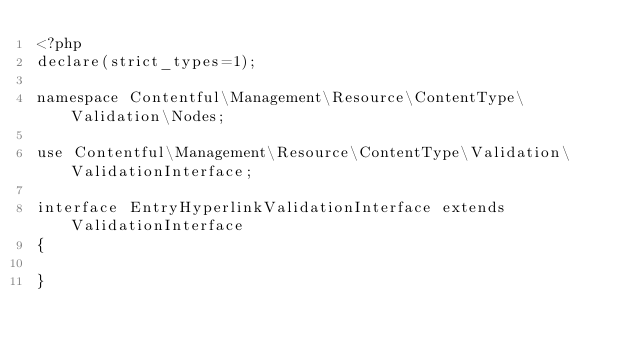Convert code to text. <code><loc_0><loc_0><loc_500><loc_500><_PHP_><?php
declare(strict_types=1);

namespace Contentful\Management\Resource\ContentType\Validation\Nodes;

use Contentful\Management\Resource\ContentType\Validation\ValidationInterface;

interface EntryHyperlinkValidationInterface extends ValidationInterface
{

}
</code> 